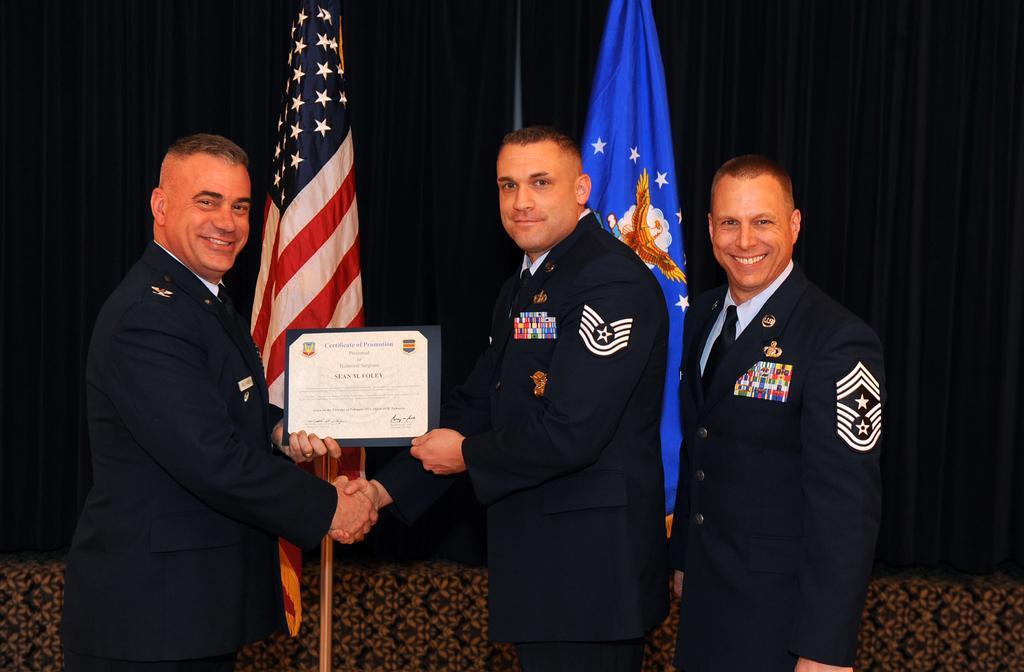Describe this image in one or two sentences. Here we can see three men posing to a camera and they are smiling. They are holding a frame with their hands. In the background we can see flags and curtains. 